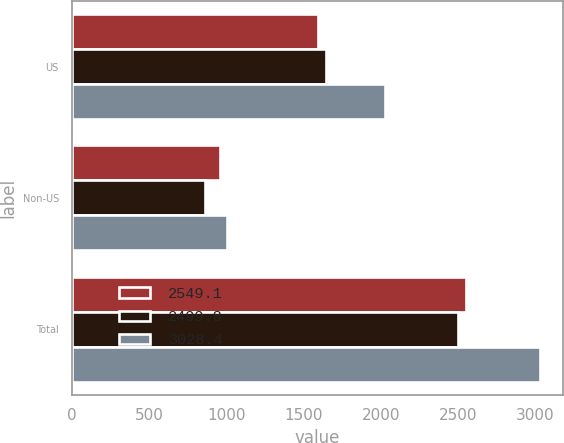Convert chart to OTSL. <chart><loc_0><loc_0><loc_500><loc_500><stacked_bar_chart><ecel><fcel>US<fcel>Non-US<fcel>Total<nl><fcel>2549.1<fcel>1594.5<fcel>954.6<fcel>2549.1<nl><fcel>2499.8<fcel>1641.7<fcel>858.1<fcel>2499.8<nl><fcel>3028.4<fcel>2026.4<fcel>1002<fcel>3028.4<nl></chart> 